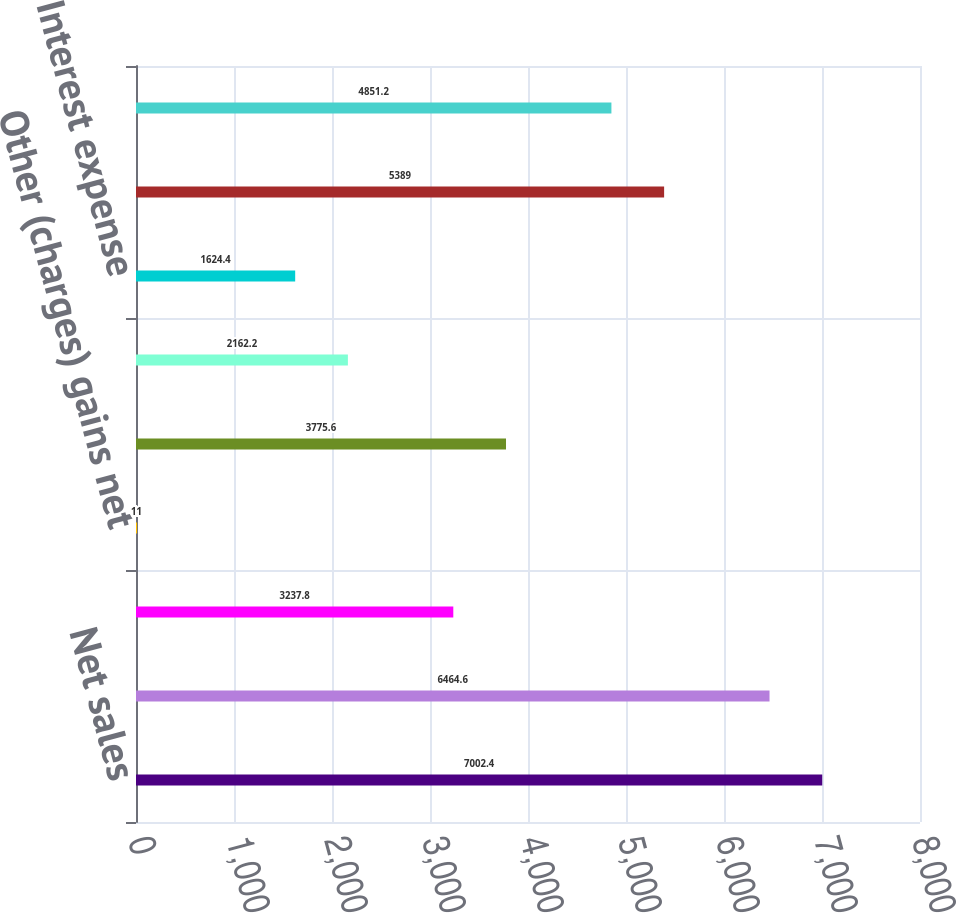Convert chart. <chart><loc_0><loc_0><loc_500><loc_500><bar_chart><fcel>Net sales<fcel>Gross profit<fcel>Selling general and<fcel>Other (charges) gains net<fcel>Operating profit (loss)<fcel>Equity in net earnings (loss)<fcel>Interest expense<fcel>Earnings (loss) from<fcel>Net earnings (loss)<nl><fcel>7002.4<fcel>6464.6<fcel>3237.8<fcel>11<fcel>3775.6<fcel>2162.2<fcel>1624.4<fcel>5389<fcel>4851.2<nl></chart> 